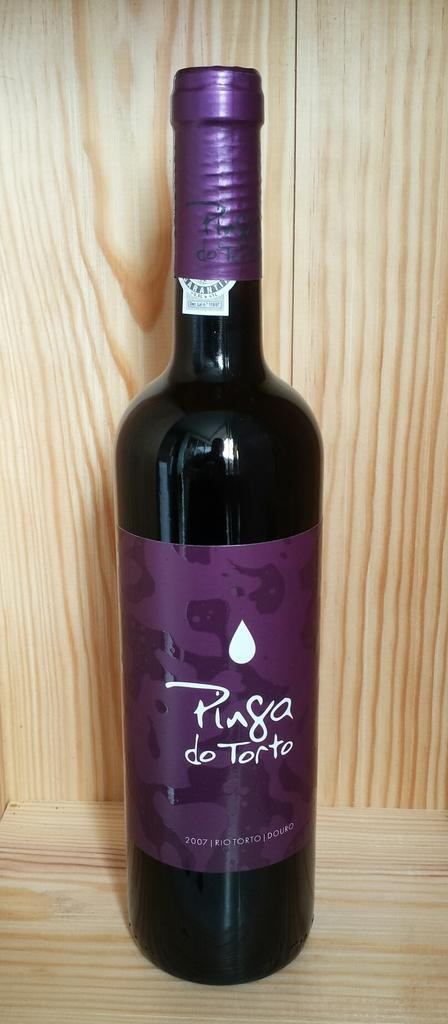Provide a one-sentence caption for the provided image. Pinga torto purple bottle that never been open. 